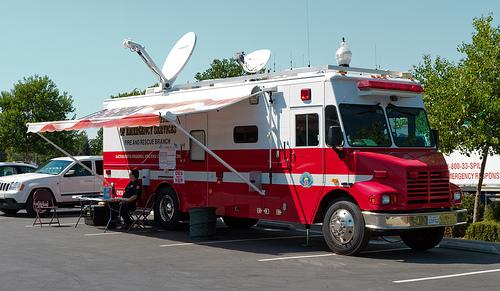What shape and color is the trash visible in the image? The trash is green and in a small black trashcan. What type of tree is present in the image, and what is its color? There is a tall, leafy green tree in the image. Assess the quality of the image based on the clarity of the objects. The image quality seems adequate, as the objects are clearly visible and easily distinguishable. Can you describe the overall sentiment the image conveys? The image conveys a sense of calm and functionality, with a man resting and various objects neatly arranged. How many dishes do you see, and what color are they? There are two dishes, and they are white. Tell me the color and type of vehicle the dishes are on. The dishes are on a red and white truck. Count the number of vehicles in the image and describe their colors. There are three vehicles: a red and white truck, a white car, and a white SUV. Identify the color of the sky and describe the weather. The sky is a clear blue, indicating good weather with no clouds. What is the man in the image doing, and where is he located? The man is sitting in a chair under an awning. Explain the interaction between the man and the surrounding objects. The man is sitting in a chair under an awning, possibly taking a break from his work with the red and white truck nearby. What is the main activity happening in the image? A man is sitting in a chair under an awning next to a red and white truck. Choose the correct description for the dishes on the truck: A) Two white dishes, B) A green dish, C) One white dish and one green dish. A) Two white dishes What color is the tree near the parking lot? Green Describe the truck in the image. The truck is red and white, has emergency lights on the front, a satellite dish on top, and an awning on the side. List the objects found in the parking lot in this image. Red and white truck, white car, green tree, chair, dishes on the truck, trashcan. Identify the emotion of the man in the image. Cannot determine emotion as the man's facial expression is not visible. What is the state of the sky in the scene? The sky is clear and cloudless. What is the color and purpose of the object found on the top of the truck? White dish receiver for satellite communication In the image, is the front wheel or the back wheel of the truck bigger? Front wheel What color is the light on the front of the truck? Red What color is the car in the image? White Which object in the image can be described as small and black? Trashcan Where is the man in the image sitting? In a chair under the awning. Explain the diagram of items found in the image. There is no diagram present in the image. What colors are present on the sign on the ambulance? Cannot determine as the sign's colors are not visible. List any object or event that could be considered an emergency in the image. There are no objects or events directly indicating an emergency, but the truck is an ambulance with emergency lights on the front. Describe the ground in the image. Clean gray concrete How many tires are visible on the truck? Two What color is the sky in the picture? Clear blue 